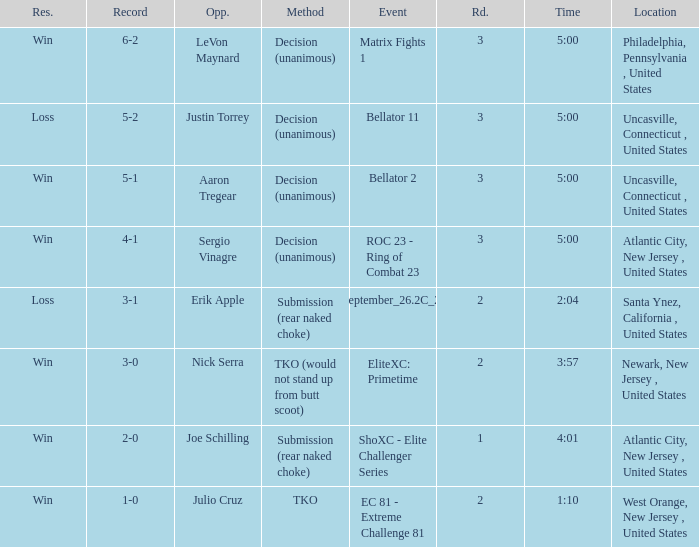What round was it when the method was TKO (would not stand up from Butt Scoot)? 2.0. Could you parse the entire table as a dict? {'header': ['Res.', 'Record', 'Opp.', 'Method', 'Event', 'Rd.', 'Time', 'Location'], 'rows': [['Win', '6-2', 'LeVon Maynard', 'Decision (unanimous)', 'Matrix Fights 1', '3', '5:00', 'Philadelphia, Pennsylvania , United States'], ['Loss', '5-2', 'Justin Torrey', 'Decision (unanimous)', 'Bellator 11', '3', '5:00', 'Uncasville, Connecticut , United States'], ['Win', '5-1', 'Aaron Tregear', 'Decision (unanimous)', 'Bellator 2', '3', '5:00', 'Uncasville, Connecticut , United States'], ['Win', '4-1', 'Sergio Vinagre', 'Decision (unanimous)', 'ROC 23 - Ring of Combat 23', '3', '5:00', 'Atlantic City, New Jersey , United States'], ['Loss', '3-1', 'Erik Apple', 'Submission (rear naked choke)', 'ShoXC#September_26.2C_2008_card', '2', '2:04', 'Santa Ynez, California , United States'], ['Win', '3-0', 'Nick Serra', 'TKO (would not stand up from butt scoot)', 'EliteXC: Primetime', '2', '3:57', 'Newark, New Jersey , United States'], ['Win', '2-0', 'Joe Schilling', 'Submission (rear naked choke)', 'ShoXC - Elite Challenger Series', '1', '4:01', 'Atlantic City, New Jersey , United States'], ['Win', '1-0', 'Julio Cruz', 'TKO', 'EC 81 - Extreme Challenge 81', '2', '1:10', 'West Orange, New Jersey , United States']]} 